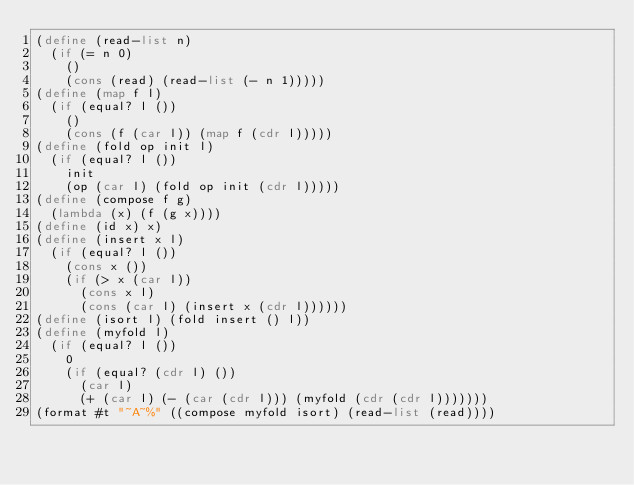Convert code to text. <code><loc_0><loc_0><loc_500><loc_500><_Scheme_>(define (read-list n)
  (if (= n 0)
    ()
    (cons (read) (read-list (- n 1)))))
(define (map f l)
  (if (equal? l ())
    ()
    (cons (f (car l)) (map f (cdr l)))))
(define (fold op init l)
  (if (equal? l ())
    init
    (op (car l) (fold op init (cdr l)))))
(define (compose f g)
  (lambda (x) (f (g x))))
(define (id x) x)
(define (insert x l)
  (if (equal? l ())
    (cons x ())
    (if (> x (car l))
      (cons x l)
      (cons (car l) (insert x (cdr l))))))
(define (isort l) (fold insert () l))
(define (myfold l)
  (if (equal? l ())
    0
    (if (equal? (cdr l) ())
      (car l)
      (+ (car l) (- (car (cdr l))) (myfold (cdr (cdr l)))))))
(format #t "~A~%" ((compose myfold isort) (read-list (read))))</code> 